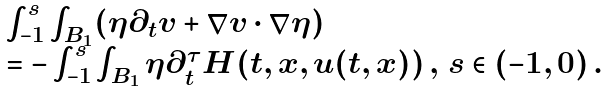<formula> <loc_0><loc_0><loc_500><loc_500>\begin{array} { l } \int _ { - 1 } ^ { s } \int _ { B _ { 1 } } ( \eta \partial _ { t } v + \nabla v \cdot \nabla \eta ) \\ = - \int _ { - 1 } ^ { s } \int _ { B _ { 1 } } \eta \partial _ { t } ^ { \tau } H ( t , x , u ( t , x ) ) \, , \, s \in ( - 1 , 0 ) \, . \end{array}</formula> 